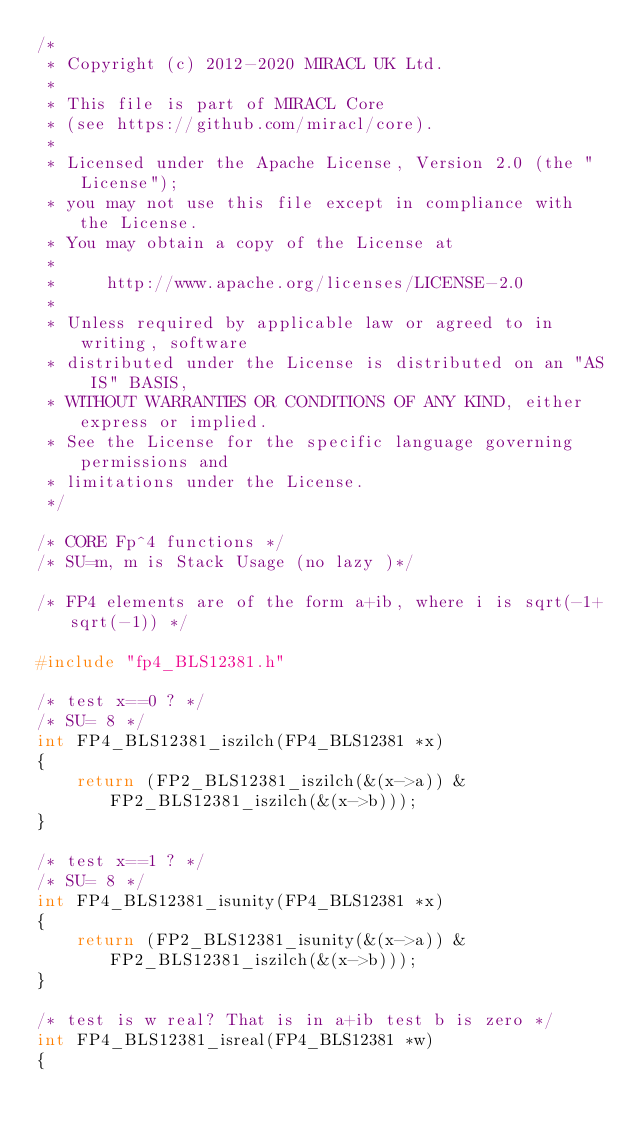Convert code to text. <code><loc_0><loc_0><loc_500><loc_500><_C_>/*
 * Copyright (c) 2012-2020 MIRACL UK Ltd.
 *
 * This file is part of MIRACL Core
 * (see https://github.com/miracl/core).
 *
 * Licensed under the Apache License, Version 2.0 (the "License");
 * you may not use this file except in compliance with the License.
 * You may obtain a copy of the License at
 *
 *     http://www.apache.org/licenses/LICENSE-2.0
 *
 * Unless required by applicable law or agreed to in writing, software
 * distributed under the License is distributed on an "AS IS" BASIS,
 * WITHOUT WARRANTIES OR CONDITIONS OF ANY KIND, either express or implied.
 * See the License for the specific language governing permissions and
 * limitations under the License.
 */

/* CORE Fp^4 functions */
/* SU=m, m is Stack Usage (no lazy )*/

/* FP4 elements are of the form a+ib, where i is sqrt(-1+sqrt(-1)) */

#include "fp4_BLS12381.h"

/* test x==0 ? */
/* SU= 8 */
int FP4_BLS12381_iszilch(FP4_BLS12381 *x)
{
    return (FP2_BLS12381_iszilch(&(x->a)) & FP2_BLS12381_iszilch(&(x->b)));
}

/* test x==1 ? */
/* SU= 8 */
int FP4_BLS12381_isunity(FP4_BLS12381 *x)
{
    return (FP2_BLS12381_isunity(&(x->a)) & FP2_BLS12381_iszilch(&(x->b)));
}

/* test is w real? That is in a+ib test b is zero */
int FP4_BLS12381_isreal(FP4_BLS12381 *w)
{</code> 